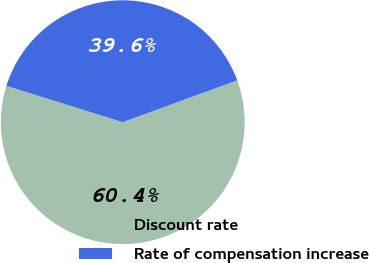<chart> <loc_0><loc_0><loc_500><loc_500><pie_chart><fcel>Discount rate<fcel>Rate of compensation increase<nl><fcel>60.4%<fcel>39.6%<nl></chart> 